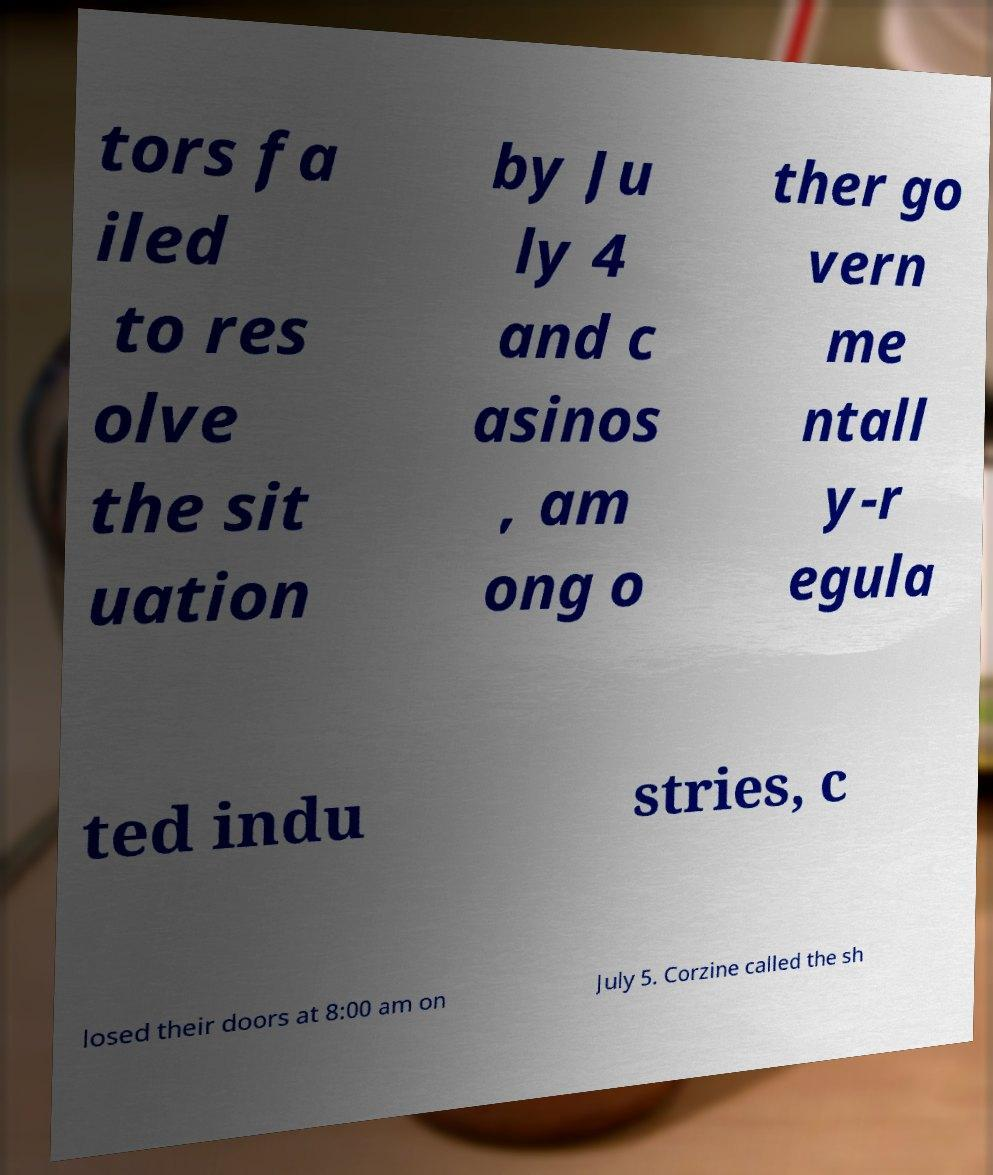Could you extract and type out the text from this image? tors fa iled to res olve the sit uation by Ju ly 4 and c asinos , am ong o ther go vern me ntall y-r egula ted indu stries, c losed their doors at 8:00 am on July 5. Corzine called the sh 